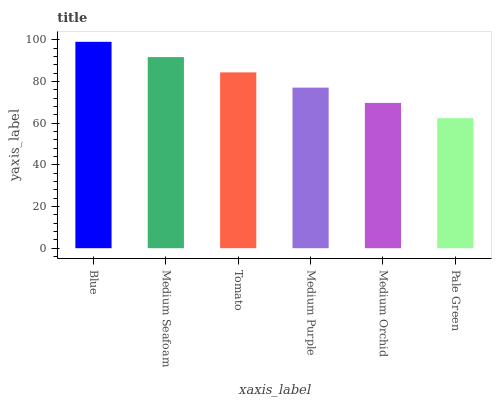Is Pale Green the minimum?
Answer yes or no. Yes. Is Blue the maximum?
Answer yes or no. Yes. Is Medium Seafoam the minimum?
Answer yes or no. No. Is Medium Seafoam the maximum?
Answer yes or no. No. Is Blue greater than Medium Seafoam?
Answer yes or no. Yes. Is Medium Seafoam less than Blue?
Answer yes or no. Yes. Is Medium Seafoam greater than Blue?
Answer yes or no. No. Is Blue less than Medium Seafoam?
Answer yes or no. No. Is Tomato the high median?
Answer yes or no. Yes. Is Medium Purple the low median?
Answer yes or no. Yes. Is Medium Purple the high median?
Answer yes or no. No. Is Tomato the low median?
Answer yes or no. No. 